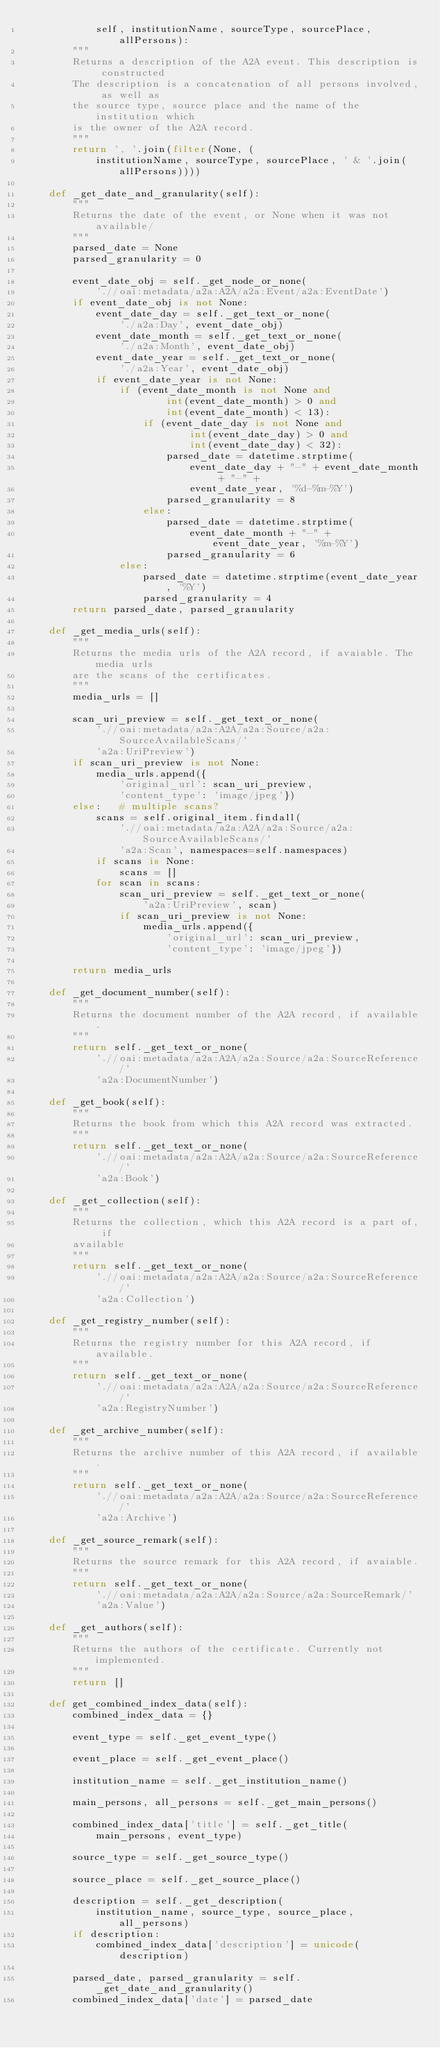<code> <loc_0><loc_0><loc_500><loc_500><_Python_>            self, institutionName, sourceType, sourcePlace, allPersons):
        """
        Returns a description of the A2A event. This description is constructed
        The description is a concatenation of all persons involved, as well as
        the source type, source place and the name of the institution which
        is the owner of the A2A record.
        """
        return ', '.join(filter(None, (
            institutionName, sourceType, sourcePlace, ' & '.join(allPersons))))

    def _get_date_and_granularity(self):
        """
        Returns the date of the event, or None when it was not available/
        """
        parsed_date = None
        parsed_granularity = 0

        event_date_obj = self._get_node_or_none(
            './/oai:metadata/a2a:A2A/a2a:Event/a2a:EventDate')
        if event_date_obj is not None:
            event_date_day = self._get_text_or_none(
                './a2a:Day', event_date_obj)
            event_date_month = self._get_text_or_none(
                './a2a:Month', event_date_obj)
            event_date_year = self._get_text_or_none(
                './a2a:Year', event_date_obj)
            if event_date_year is not None:
                if (event_date_month is not None and
                        int(event_date_month) > 0 and
                        int(event_date_month) < 13):
                    if (event_date_day is not None and
                            int(event_date_day) > 0 and
                            int(event_date_day) < 32):
                        parsed_date = datetime.strptime(
                            event_date_day + "-" + event_date_month + "-" +
                            event_date_year, '%d-%m-%Y')
                        parsed_granularity = 8
                    else:
                        parsed_date = datetime.strptime(
                            event_date_month + "-" + event_date_year, '%m-%Y')
                        parsed_granularity = 6
                else:
                    parsed_date = datetime.strptime(event_date_year, '%Y')
                    parsed_granularity = 4
        return parsed_date, parsed_granularity

    def _get_media_urls(self):
        """
        Returns the media urls of the A2A record, if avaiable. The media urls
        are the scans of the certificates.
        """
        media_urls = []

        scan_uri_preview = self._get_text_or_none(
            './/oai:metadata/a2a:A2A/a2a:Source/a2a:SourceAvailableScans/'
            'a2a:UriPreview')
        if scan_uri_preview is not None:
            media_urls.append({
                'original_url': scan_uri_preview,
                'content_type': 'image/jpeg'})
        else:   # multiple scans?
            scans = self.original_item.findall(
                './/oai:metadata/a2a:A2A/a2a:Source/a2a:SourceAvailableScans/'
                'a2a:Scan', namespaces=self.namespaces)
            if scans is None:
                scans = []
            for scan in scans:
                scan_uri_preview = self._get_text_or_none(
                    'a2a:UriPreview', scan)
                if scan_uri_preview is not None:
                    media_urls.append({
                        'original_url': scan_uri_preview,
                        'content_type': 'image/jpeg'})

        return media_urls

    def _get_document_number(self):
        """
        Returns the document number of the A2A record, if available.
        """
        return self._get_text_or_none(
            './/oai:metadata/a2a:A2A/a2a:Source/a2a:SourceReference/'
            'a2a:DocumentNumber')

    def _get_book(self):
        """
        Returns the book from which this A2A record was extracted.
        """
        return self._get_text_or_none(
            './/oai:metadata/a2a:A2A/a2a:Source/a2a:SourceReference/'
            'a2a:Book')

    def _get_collection(self):
        """
        Returns the collection, which this A2A record is a part of, if
        available
        """
        return self._get_text_or_none(
            './/oai:metadata/a2a:A2A/a2a:Source/a2a:SourceReference/'
            'a2a:Collection')

    def _get_registry_number(self):
        """
        Returns the registry number for this A2A record, if available.
        """
        return self._get_text_or_none(
            './/oai:metadata/a2a:A2A/a2a:Source/a2a:SourceReference/'
            'a2a:RegistryNumber')

    def _get_archive_number(self):
        """
        Returns the archive number of this A2A record, if available.
        """
        return self._get_text_or_none(
            './/oai:metadata/a2a:A2A/a2a:Source/a2a:SourceReference/'
            'a2a:Archive')

    def _get_source_remark(self):
        """
        Returns the source remark for this A2A record, if avaiable.
        """
        return self._get_text_or_none(
            './/oai:metadata/a2a:A2A/a2a:Source/a2a:SourceRemark/'
            'a2a:Value')

    def _get_authors(self):
        """
        Returns the authors of the certificate. Currently not implemented.
        """
        return []

    def get_combined_index_data(self):
        combined_index_data = {}

        event_type = self._get_event_type()

        event_place = self._get_event_place()

        institution_name = self._get_institution_name()

        main_persons, all_persons = self._get_main_persons()

        combined_index_data['title'] = self._get_title(
            main_persons, event_type)

        source_type = self._get_source_type()

        source_place = self._get_source_place()

        description = self._get_description(
            institution_name, source_type, source_place, all_persons)
        if description:
            combined_index_data['description'] = unicode(description)

        parsed_date, parsed_granularity = self._get_date_and_granularity()
        combined_index_data['date'] = parsed_date</code> 